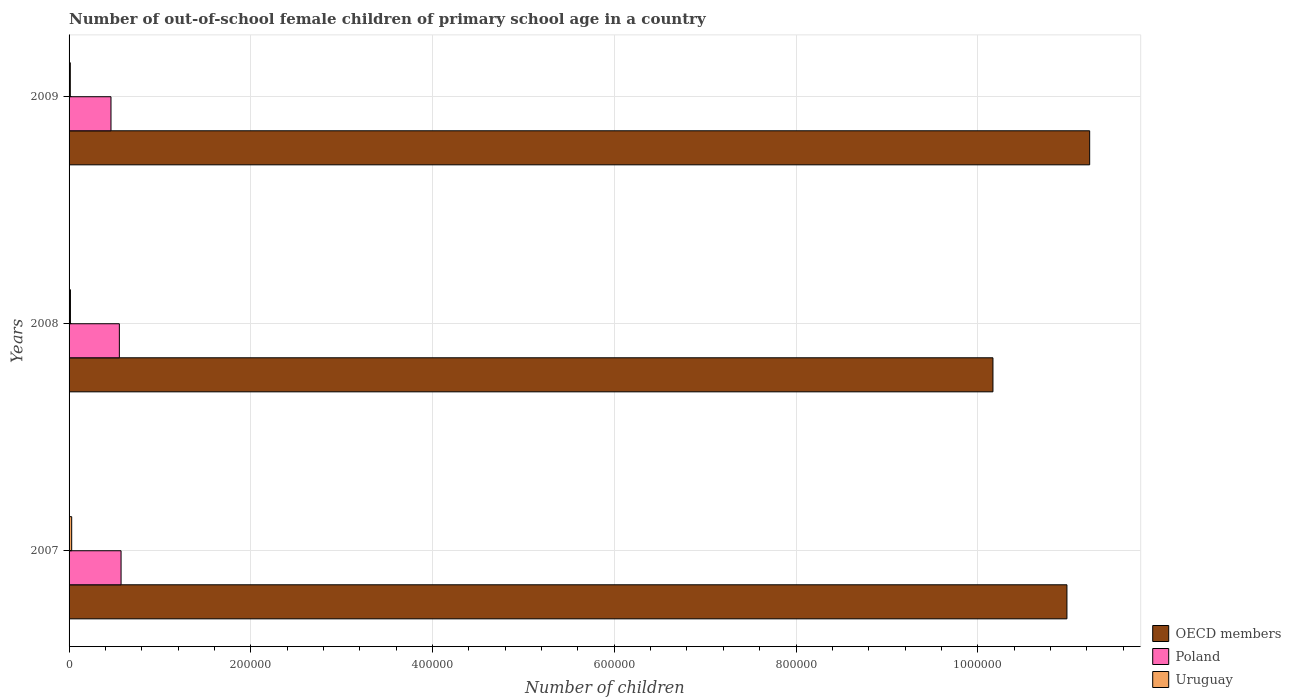How many different coloured bars are there?
Offer a very short reply. 3. Are the number of bars per tick equal to the number of legend labels?
Ensure brevity in your answer.  Yes. How many bars are there on the 1st tick from the top?
Provide a short and direct response. 3. What is the label of the 3rd group of bars from the top?
Your answer should be very brief. 2007. What is the number of out-of-school female children in Uruguay in 2008?
Your response must be concise. 1505. Across all years, what is the maximum number of out-of-school female children in Poland?
Offer a very short reply. 5.72e+04. Across all years, what is the minimum number of out-of-school female children in Poland?
Make the answer very short. 4.61e+04. In which year was the number of out-of-school female children in OECD members minimum?
Keep it short and to the point. 2008. What is the total number of out-of-school female children in Poland in the graph?
Provide a succinct answer. 1.59e+05. What is the difference between the number of out-of-school female children in OECD members in 2007 and that in 2008?
Provide a short and direct response. 8.14e+04. What is the difference between the number of out-of-school female children in Poland in 2009 and the number of out-of-school female children in OECD members in 2007?
Your response must be concise. -1.05e+06. What is the average number of out-of-school female children in Uruguay per year?
Your answer should be compact. 1915.33. In the year 2007, what is the difference between the number of out-of-school female children in Poland and number of out-of-school female children in OECD members?
Provide a succinct answer. -1.04e+06. What is the ratio of the number of out-of-school female children in OECD members in 2007 to that in 2008?
Offer a terse response. 1.08. Is the number of out-of-school female children in OECD members in 2007 less than that in 2008?
Ensure brevity in your answer.  No. What is the difference between the highest and the second highest number of out-of-school female children in OECD members?
Make the answer very short. 2.50e+04. What is the difference between the highest and the lowest number of out-of-school female children in OECD members?
Keep it short and to the point. 1.06e+05. Is the sum of the number of out-of-school female children in Poland in 2008 and 2009 greater than the maximum number of out-of-school female children in Uruguay across all years?
Keep it short and to the point. Yes. What does the 2nd bar from the bottom in 2007 represents?
Ensure brevity in your answer.  Poland. How many bars are there?
Provide a short and direct response. 9. What is the difference between two consecutive major ticks on the X-axis?
Offer a very short reply. 2.00e+05. Are the values on the major ticks of X-axis written in scientific E-notation?
Offer a very short reply. No. Does the graph contain any zero values?
Offer a terse response. No. Does the graph contain grids?
Offer a terse response. Yes. Where does the legend appear in the graph?
Give a very brief answer. Bottom right. How many legend labels are there?
Offer a terse response. 3. How are the legend labels stacked?
Ensure brevity in your answer.  Vertical. What is the title of the graph?
Make the answer very short. Number of out-of-school female children of primary school age in a country. Does "Armenia" appear as one of the legend labels in the graph?
Keep it short and to the point. No. What is the label or title of the X-axis?
Keep it short and to the point. Number of children. What is the label or title of the Y-axis?
Your answer should be very brief. Years. What is the Number of children in OECD members in 2007?
Provide a short and direct response. 1.10e+06. What is the Number of children in Poland in 2007?
Give a very brief answer. 5.72e+04. What is the Number of children of Uruguay in 2007?
Give a very brief answer. 2877. What is the Number of children in OECD members in 2008?
Give a very brief answer. 1.02e+06. What is the Number of children in Poland in 2008?
Give a very brief answer. 5.53e+04. What is the Number of children in Uruguay in 2008?
Give a very brief answer. 1505. What is the Number of children of OECD members in 2009?
Make the answer very short. 1.12e+06. What is the Number of children of Poland in 2009?
Keep it short and to the point. 4.61e+04. What is the Number of children in Uruguay in 2009?
Keep it short and to the point. 1364. Across all years, what is the maximum Number of children of OECD members?
Offer a terse response. 1.12e+06. Across all years, what is the maximum Number of children of Poland?
Offer a terse response. 5.72e+04. Across all years, what is the maximum Number of children in Uruguay?
Offer a very short reply. 2877. Across all years, what is the minimum Number of children of OECD members?
Your response must be concise. 1.02e+06. Across all years, what is the minimum Number of children of Poland?
Ensure brevity in your answer.  4.61e+04. Across all years, what is the minimum Number of children in Uruguay?
Provide a succinct answer. 1364. What is the total Number of children in OECD members in the graph?
Give a very brief answer. 3.24e+06. What is the total Number of children in Poland in the graph?
Offer a very short reply. 1.59e+05. What is the total Number of children in Uruguay in the graph?
Provide a succinct answer. 5746. What is the difference between the Number of children in OECD members in 2007 and that in 2008?
Make the answer very short. 8.14e+04. What is the difference between the Number of children in Poland in 2007 and that in 2008?
Give a very brief answer. 1880. What is the difference between the Number of children of Uruguay in 2007 and that in 2008?
Make the answer very short. 1372. What is the difference between the Number of children of OECD members in 2007 and that in 2009?
Give a very brief answer. -2.50e+04. What is the difference between the Number of children of Poland in 2007 and that in 2009?
Make the answer very short. 1.11e+04. What is the difference between the Number of children in Uruguay in 2007 and that in 2009?
Give a very brief answer. 1513. What is the difference between the Number of children of OECD members in 2008 and that in 2009?
Ensure brevity in your answer.  -1.06e+05. What is the difference between the Number of children in Poland in 2008 and that in 2009?
Your answer should be compact. 9220. What is the difference between the Number of children in Uruguay in 2008 and that in 2009?
Offer a terse response. 141. What is the difference between the Number of children of OECD members in 2007 and the Number of children of Poland in 2008?
Ensure brevity in your answer.  1.04e+06. What is the difference between the Number of children of OECD members in 2007 and the Number of children of Uruguay in 2008?
Ensure brevity in your answer.  1.10e+06. What is the difference between the Number of children of Poland in 2007 and the Number of children of Uruguay in 2008?
Offer a very short reply. 5.57e+04. What is the difference between the Number of children in OECD members in 2007 and the Number of children in Poland in 2009?
Your answer should be compact. 1.05e+06. What is the difference between the Number of children in OECD members in 2007 and the Number of children in Uruguay in 2009?
Give a very brief answer. 1.10e+06. What is the difference between the Number of children of Poland in 2007 and the Number of children of Uruguay in 2009?
Your response must be concise. 5.59e+04. What is the difference between the Number of children of OECD members in 2008 and the Number of children of Poland in 2009?
Provide a succinct answer. 9.71e+05. What is the difference between the Number of children in OECD members in 2008 and the Number of children in Uruguay in 2009?
Provide a short and direct response. 1.02e+06. What is the difference between the Number of children in Poland in 2008 and the Number of children in Uruguay in 2009?
Offer a terse response. 5.40e+04. What is the average Number of children in OECD members per year?
Offer a terse response. 1.08e+06. What is the average Number of children in Poland per year?
Provide a short and direct response. 5.29e+04. What is the average Number of children in Uruguay per year?
Give a very brief answer. 1915.33. In the year 2007, what is the difference between the Number of children of OECD members and Number of children of Poland?
Your response must be concise. 1.04e+06. In the year 2007, what is the difference between the Number of children in OECD members and Number of children in Uruguay?
Your answer should be compact. 1.10e+06. In the year 2007, what is the difference between the Number of children in Poland and Number of children in Uruguay?
Your answer should be very brief. 5.43e+04. In the year 2008, what is the difference between the Number of children in OECD members and Number of children in Poland?
Offer a very short reply. 9.61e+05. In the year 2008, what is the difference between the Number of children in OECD members and Number of children in Uruguay?
Your answer should be very brief. 1.02e+06. In the year 2008, what is the difference between the Number of children of Poland and Number of children of Uruguay?
Your response must be concise. 5.38e+04. In the year 2009, what is the difference between the Number of children in OECD members and Number of children in Poland?
Your response must be concise. 1.08e+06. In the year 2009, what is the difference between the Number of children in OECD members and Number of children in Uruguay?
Ensure brevity in your answer.  1.12e+06. In the year 2009, what is the difference between the Number of children in Poland and Number of children in Uruguay?
Provide a short and direct response. 4.48e+04. What is the ratio of the Number of children in OECD members in 2007 to that in 2008?
Keep it short and to the point. 1.08. What is the ratio of the Number of children of Poland in 2007 to that in 2008?
Your answer should be compact. 1.03. What is the ratio of the Number of children in Uruguay in 2007 to that in 2008?
Your answer should be compact. 1.91. What is the ratio of the Number of children of OECD members in 2007 to that in 2009?
Offer a terse response. 0.98. What is the ratio of the Number of children in Poland in 2007 to that in 2009?
Your answer should be very brief. 1.24. What is the ratio of the Number of children in Uruguay in 2007 to that in 2009?
Your answer should be very brief. 2.11. What is the ratio of the Number of children in OECD members in 2008 to that in 2009?
Give a very brief answer. 0.91. What is the ratio of the Number of children in Poland in 2008 to that in 2009?
Offer a very short reply. 1.2. What is the ratio of the Number of children of Uruguay in 2008 to that in 2009?
Offer a terse response. 1.1. What is the difference between the highest and the second highest Number of children of OECD members?
Your response must be concise. 2.50e+04. What is the difference between the highest and the second highest Number of children of Poland?
Provide a succinct answer. 1880. What is the difference between the highest and the second highest Number of children of Uruguay?
Your answer should be very brief. 1372. What is the difference between the highest and the lowest Number of children in OECD members?
Provide a short and direct response. 1.06e+05. What is the difference between the highest and the lowest Number of children of Poland?
Your answer should be compact. 1.11e+04. What is the difference between the highest and the lowest Number of children in Uruguay?
Keep it short and to the point. 1513. 